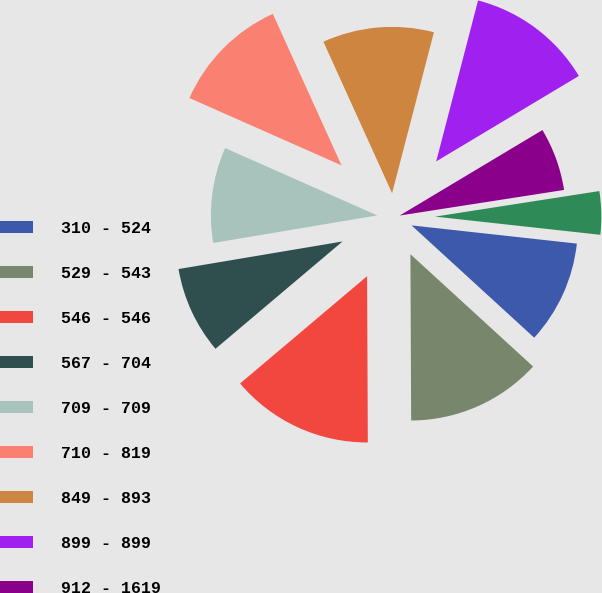Convert chart to OTSL. <chart><loc_0><loc_0><loc_500><loc_500><pie_chart><fcel>310 - 524<fcel>529 - 543<fcel>546 - 546<fcel>567 - 704<fcel>709 - 709<fcel>710 - 819<fcel>849 - 893<fcel>899 - 899<fcel>912 - 1619<fcel>1781 - 3500<nl><fcel>10.05%<fcel>13.13%<fcel>13.9%<fcel>8.51%<fcel>9.28%<fcel>11.59%<fcel>10.82%<fcel>12.36%<fcel>6.13%<fcel>4.2%<nl></chart> 